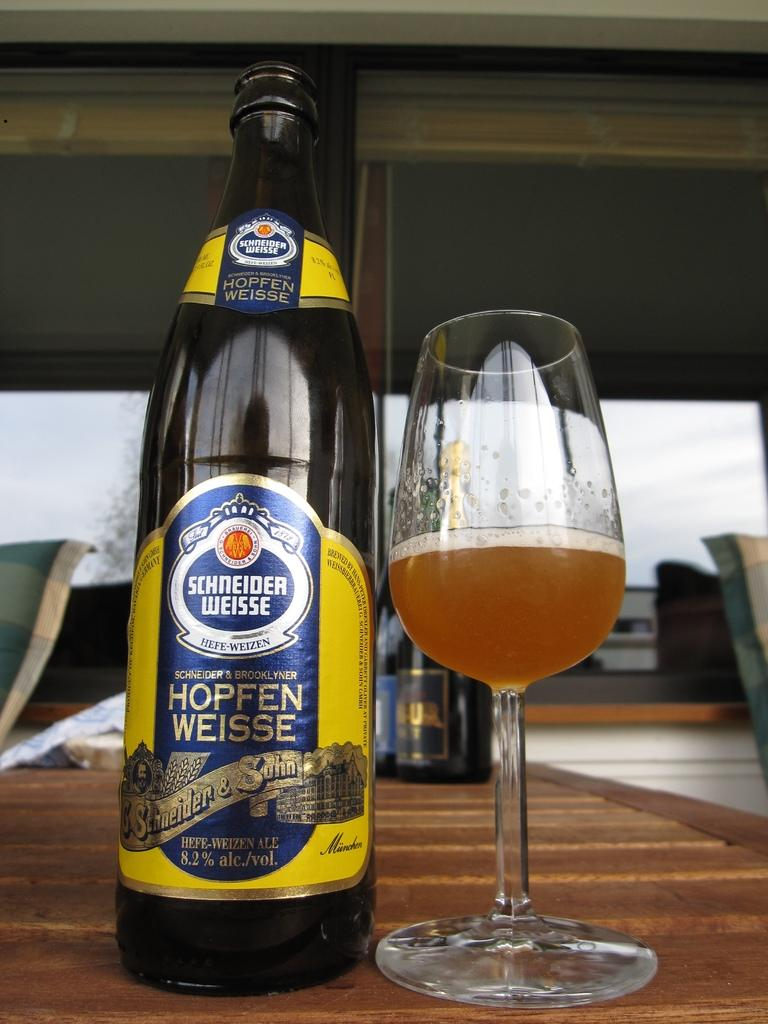Provide a one-sentence caption for the provided image. Bottle of Schneider Weisse next to a half filled glass of beer. 